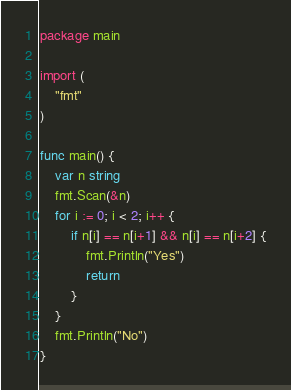Convert code to text. <code><loc_0><loc_0><loc_500><loc_500><_Go_>package main

import (
	"fmt"
)

func main() {
	var n string
	fmt.Scan(&n)
	for i := 0; i < 2; i++ {
		if n[i] == n[i+1] && n[i] == n[i+2] {
			fmt.Println("Yes")
			return
		}
	}
	fmt.Println("No")
}</code> 